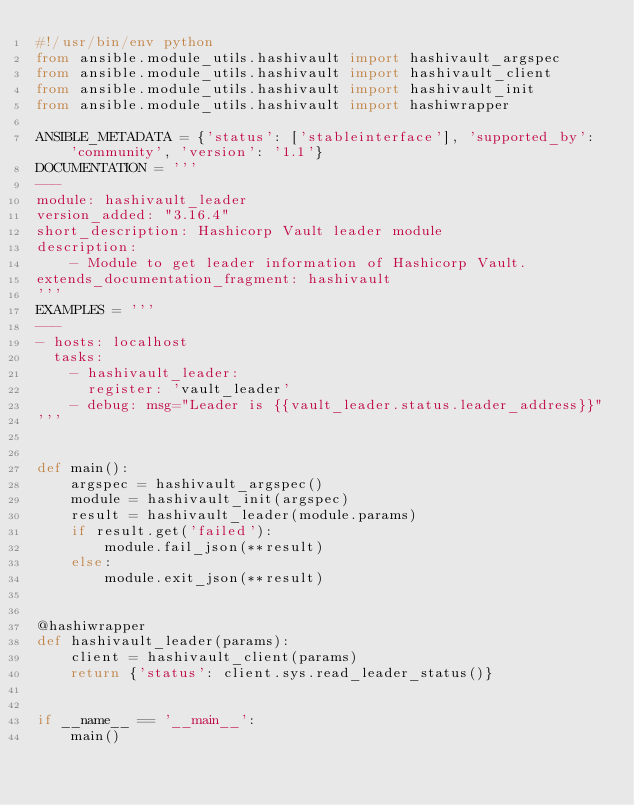Convert code to text. <code><loc_0><loc_0><loc_500><loc_500><_Python_>#!/usr/bin/env python
from ansible.module_utils.hashivault import hashivault_argspec
from ansible.module_utils.hashivault import hashivault_client
from ansible.module_utils.hashivault import hashivault_init
from ansible.module_utils.hashivault import hashiwrapper

ANSIBLE_METADATA = {'status': ['stableinterface'], 'supported_by': 'community', 'version': '1.1'}
DOCUMENTATION = '''
---
module: hashivault_leader
version_added: "3.16.4"
short_description: Hashicorp Vault leader module
description:
    - Module to get leader information of Hashicorp Vault.
extends_documentation_fragment: hashivault
'''
EXAMPLES = '''
---
- hosts: localhost
  tasks:
    - hashivault_leader:
      register: 'vault_leader'
    - debug: msg="Leader is {{vault_leader.status.leader_address}}"
'''


def main():
    argspec = hashivault_argspec()
    module = hashivault_init(argspec)
    result = hashivault_leader(module.params)
    if result.get('failed'):
        module.fail_json(**result)
    else:
        module.exit_json(**result)


@hashiwrapper
def hashivault_leader(params):
    client = hashivault_client(params)
    return {'status': client.sys.read_leader_status()}


if __name__ == '__main__':
    main()
</code> 